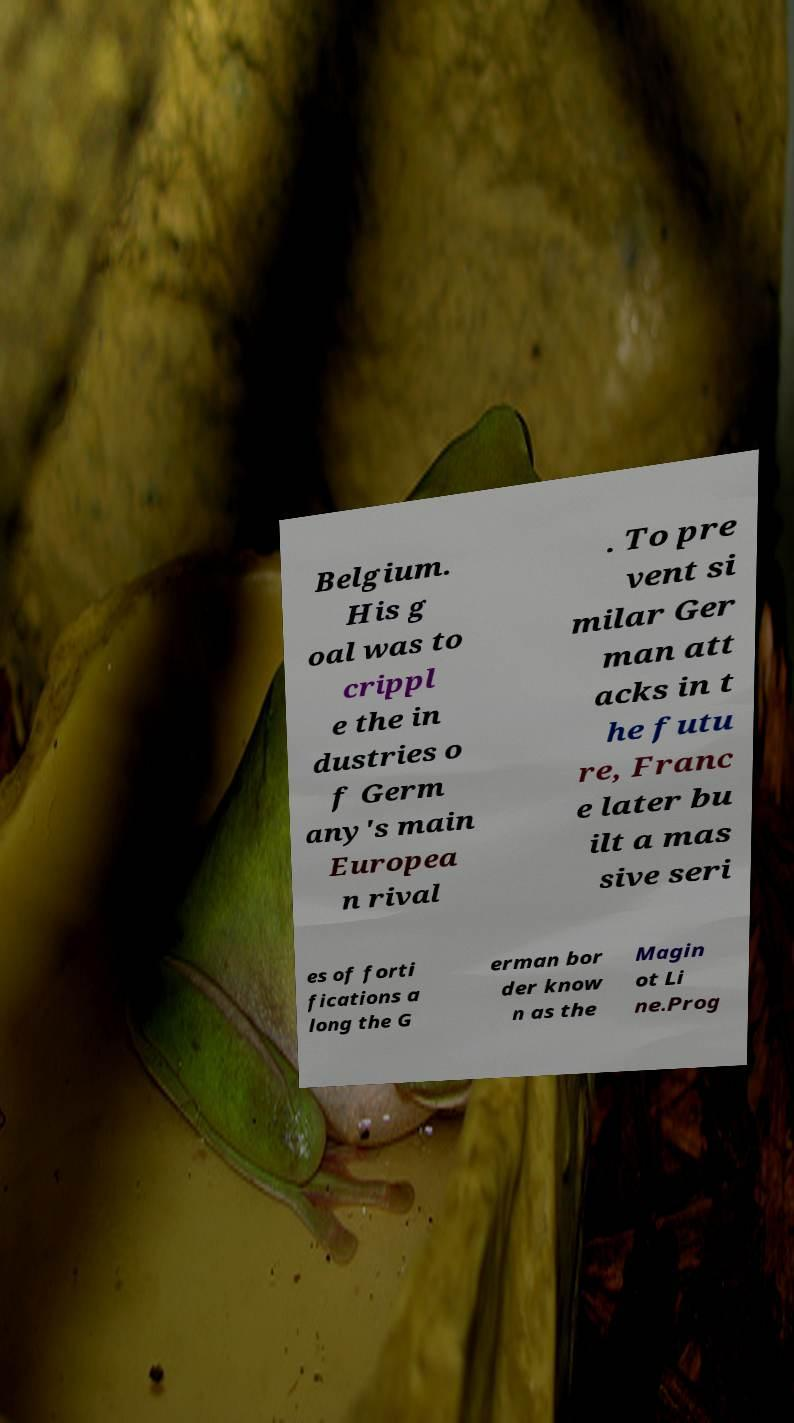Please identify and transcribe the text found in this image. Belgium. His g oal was to crippl e the in dustries o f Germ any's main Europea n rival . To pre vent si milar Ger man att acks in t he futu re, Franc e later bu ilt a mas sive seri es of forti fications a long the G erman bor der know n as the Magin ot Li ne.Prog 